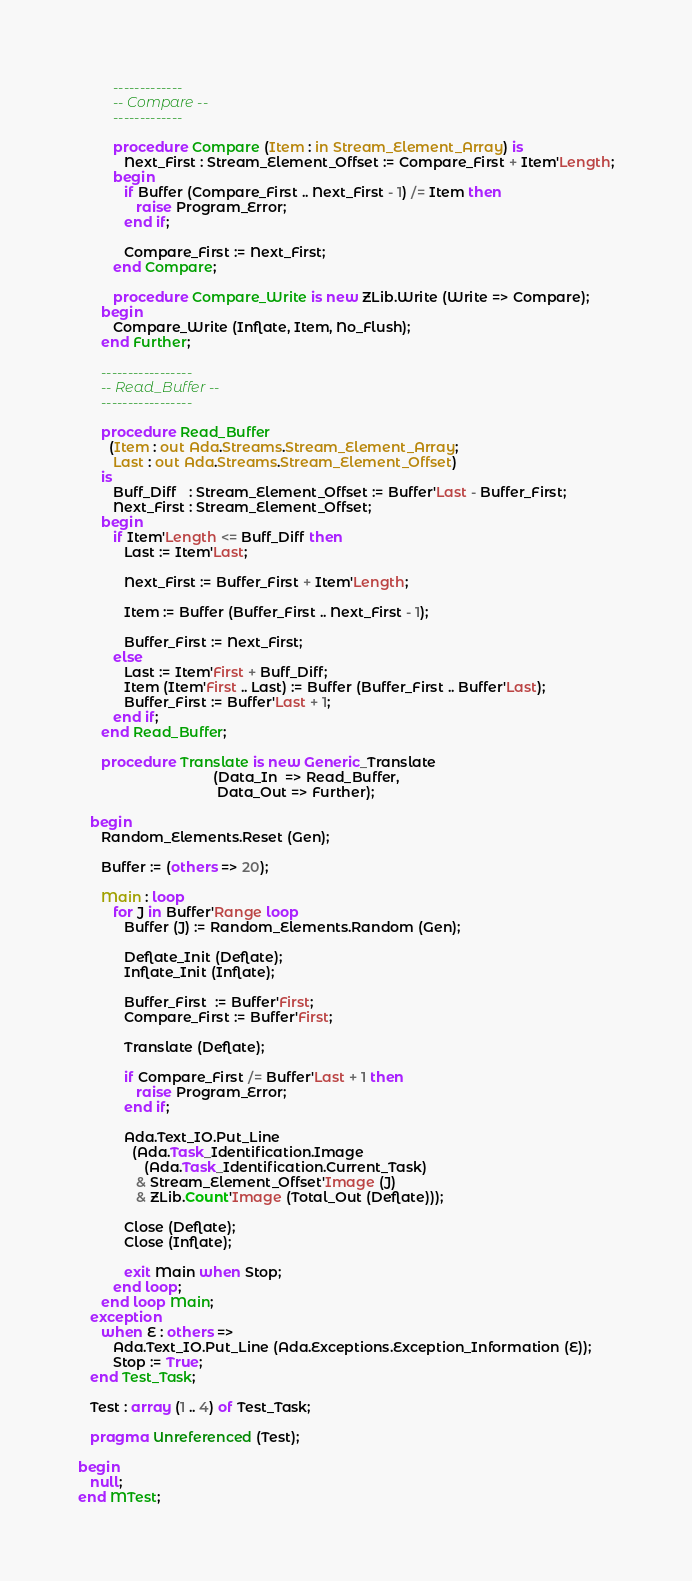Convert code to text. <code><loc_0><loc_0><loc_500><loc_500><_Ada_>         -------------
         -- Compare --
         -------------

         procedure Compare (Item : in Stream_Element_Array) is
            Next_First : Stream_Element_Offset := Compare_First + Item'Length;
         begin
            if Buffer (Compare_First .. Next_First - 1) /= Item then
               raise Program_Error;
            end if;

            Compare_First := Next_First;
         end Compare;

         procedure Compare_Write is new ZLib.Write (Write => Compare);
      begin
         Compare_Write (Inflate, Item, No_Flush);
      end Further;

      -----------------
      -- Read_Buffer --
      -----------------

      procedure Read_Buffer
        (Item : out Ada.Streams.Stream_Element_Array;
         Last : out Ada.Streams.Stream_Element_Offset)
      is
         Buff_Diff   : Stream_Element_Offset := Buffer'Last - Buffer_First;
         Next_First : Stream_Element_Offset;
      begin
         if Item'Length <= Buff_Diff then
            Last := Item'Last;

            Next_First := Buffer_First + Item'Length;

            Item := Buffer (Buffer_First .. Next_First - 1);

            Buffer_First := Next_First;
         else
            Last := Item'First + Buff_Diff;
            Item (Item'First .. Last) := Buffer (Buffer_First .. Buffer'Last);
            Buffer_First := Buffer'Last + 1;
         end if;
      end Read_Buffer;

      procedure Translate is new Generic_Translate
                                   (Data_In  => Read_Buffer,
                                    Data_Out => Further);

   begin
      Random_Elements.Reset (Gen);

      Buffer := (others => 20);

      Main : loop
         for J in Buffer'Range loop
            Buffer (J) := Random_Elements.Random (Gen);

            Deflate_Init (Deflate);
            Inflate_Init (Inflate);

            Buffer_First  := Buffer'First;
            Compare_First := Buffer'First;

            Translate (Deflate);

            if Compare_First /= Buffer'Last + 1 then
               raise Program_Error;
            end if;

            Ada.Text_IO.Put_Line
              (Ada.Task_Identification.Image
                 (Ada.Task_Identification.Current_Task)
               & Stream_Element_Offset'Image (J)
               & ZLib.Count'Image (Total_Out (Deflate)));

            Close (Deflate);
            Close (Inflate);

            exit Main when Stop;
         end loop;
      end loop Main;
   exception
      when E : others =>
         Ada.Text_IO.Put_Line (Ada.Exceptions.Exception_Information (E));
         Stop := True;
   end Test_Task;

   Test : array (1 .. 4) of Test_Task;

   pragma Unreferenced (Test);

begin
   null;
end MTest;
</code> 